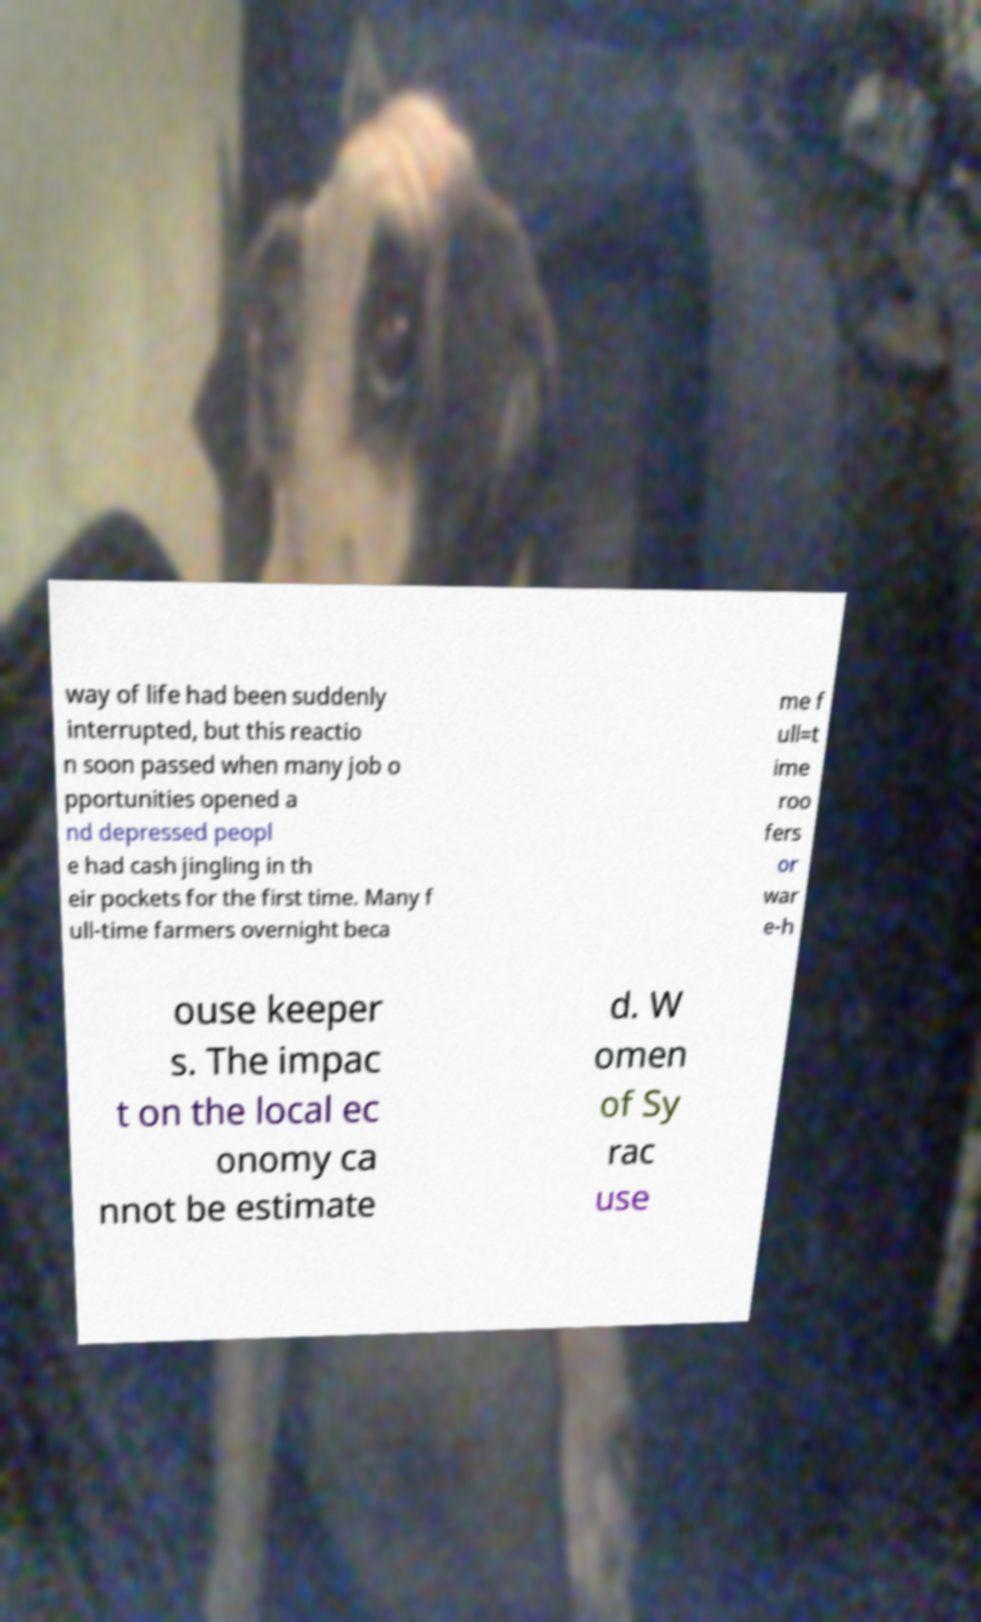Please identify and transcribe the text found in this image. way of life had been suddenly interrupted, but this reactio n soon passed when many job o pportunities opened a nd depressed peopl e had cash jingling in th eir pockets for the first time. Many f ull-time farmers overnight beca me f ull=t ime roo fers or war e-h ouse keeper s. The impac t on the local ec onomy ca nnot be estimate d. W omen of Sy rac use 